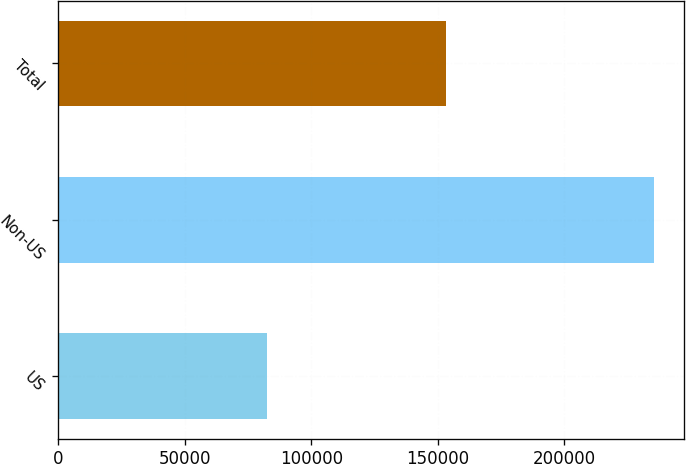Convert chart to OTSL. <chart><loc_0><loc_0><loc_500><loc_500><bar_chart><fcel>US<fcel>Non-US<fcel>Total<nl><fcel>82253<fcel>235585<fcel>153332<nl></chart> 